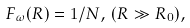Convert formula to latex. <formula><loc_0><loc_0><loc_500><loc_500>F _ { \omega } ( R ) = 1 / N , \, ( R \gg R _ { 0 } ) ,</formula> 